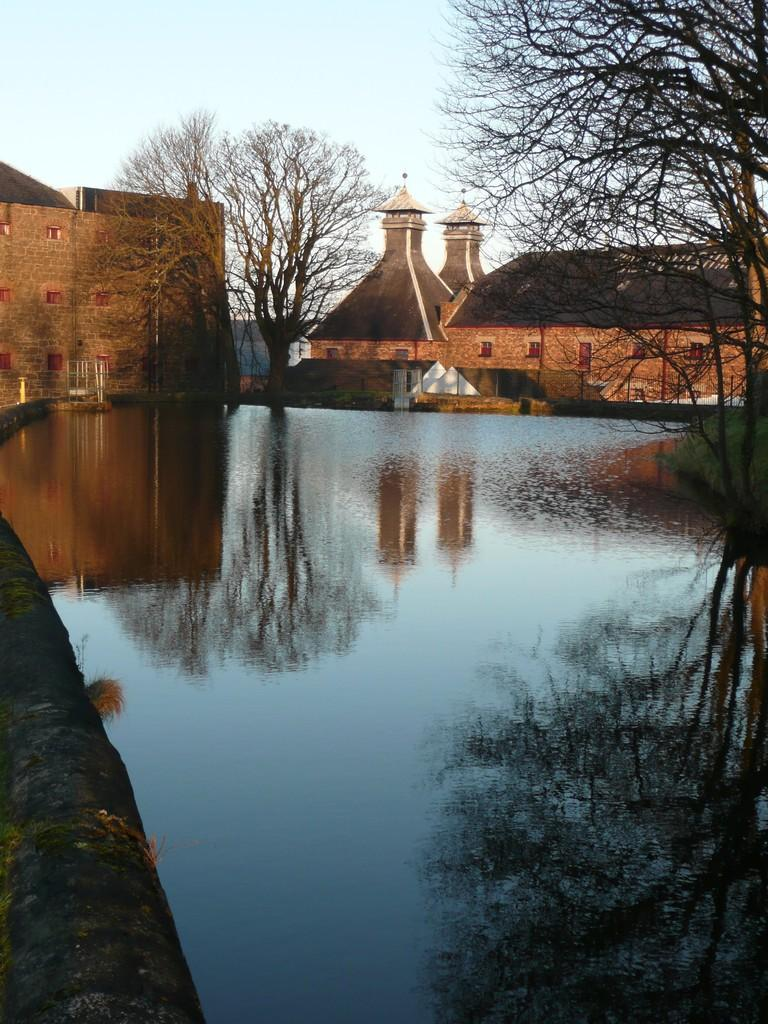What type of structures can be seen in the image? There are many houses in the image. What natural feature is present alongside the houses? There are trees alongside the river in the image. What is the main water body visible in the image? The river is visible in the image. How many pizzas are being served at the government meeting in the image? There is no mention of pizzas or a government meeting in the image; it features houses, trees, and a river. 